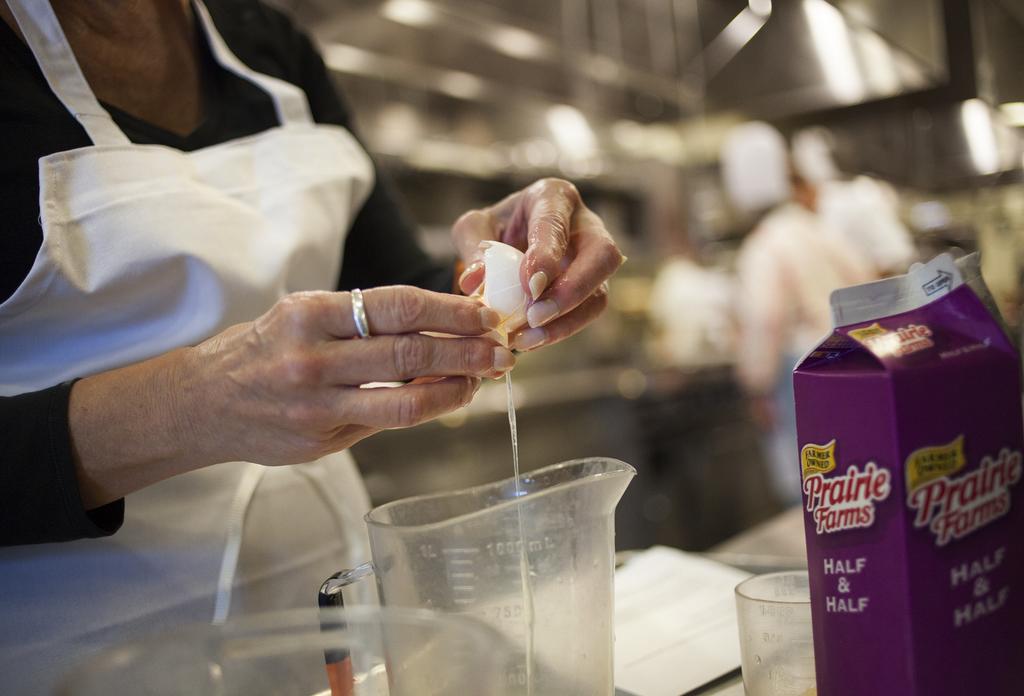Is this cream in the container?
Ensure brevity in your answer.  Yes. What is the brand?
Make the answer very short. Prairie farms. 